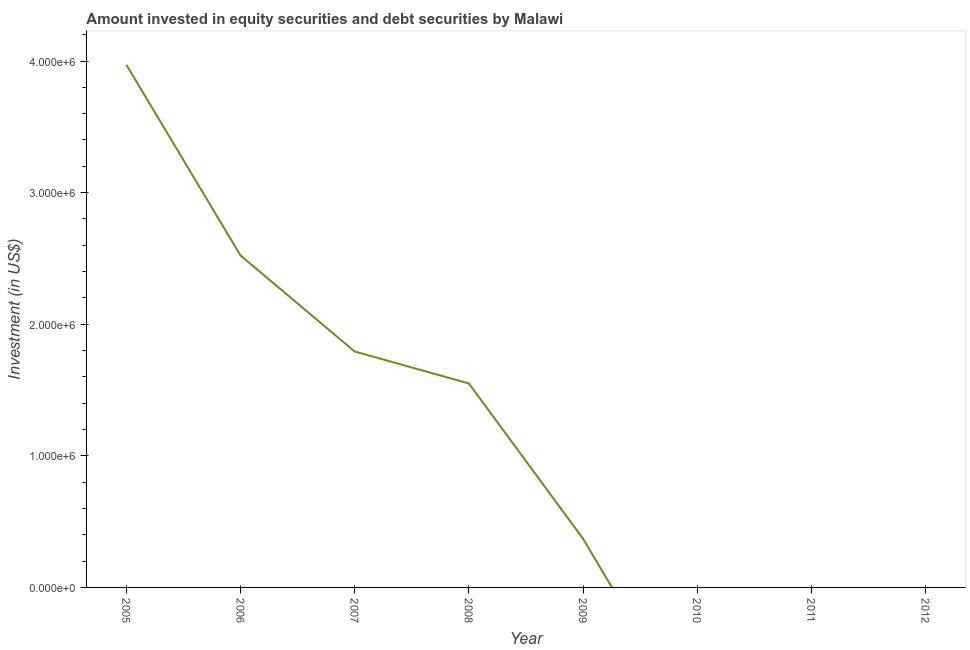What is the portfolio investment in 2007?
Keep it short and to the point. 1.79e+06. Across all years, what is the maximum portfolio investment?
Offer a terse response. 3.97e+06. In which year was the portfolio investment maximum?
Make the answer very short. 2005. What is the sum of the portfolio investment?
Provide a short and direct response. 1.02e+07. What is the difference between the portfolio investment in 2006 and 2009?
Provide a short and direct response. 2.15e+06. What is the average portfolio investment per year?
Give a very brief answer. 1.28e+06. What is the median portfolio investment?
Keep it short and to the point. 9.60e+05. In how many years, is the portfolio investment greater than 1400000 US$?
Provide a short and direct response. 4. What is the ratio of the portfolio investment in 2007 to that in 2008?
Offer a very short reply. 1.16. Is the portfolio investment in 2005 less than that in 2007?
Give a very brief answer. No. Is the difference between the portfolio investment in 2007 and 2009 greater than the difference between any two years?
Your answer should be very brief. No. What is the difference between the highest and the second highest portfolio investment?
Provide a short and direct response. 1.45e+06. What is the difference between the highest and the lowest portfolio investment?
Provide a succinct answer. 3.97e+06. In how many years, is the portfolio investment greater than the average portfolio investment taken over all years?
Provide a short and direct response. 4. Does the portfolio investment monotonically increase over the years?
Offer a terse response. No. How many years are there in the graph?
Provide a short and direct response. 8. Are the values on the major ticks of Y-axis written in scientific E-notation?
Your answer should be very brief. Yes. Does the graph contain grids?
Offer a terse response. No. What is the title of the graph?
Your answer should be very brief. Amount invested in equity securities and debt securities by Malawi. What is the label or title of the X-axis?
Make the answer very short. Year. What is the label or title of the Y-axis?
Offer a very short reply. Investment (in US$). What is the Investment (in US$) in 2005?
Offer a very short reply. 3.97e+06. What is the Investment (in US$) of 2006?
Your response must be concise. 2.52e+06. What is the Investment (in US$) of 2007?
Your answer should be compact. 1.79e+06. What is the Investment (in US$) in 2008?
Give a very brief answer. 1.55e+06. What is the Investment (in US$) of 2009?
Offer a very short reply. 3.70e+05. What is the Investment (in US$) in 2010?
Keep it short and to the point. 0. What is the Investment (in US$) of 2011?
Offer a very short reply. 0. What is the difference between the Investment (in US$) in 2005 and 2006?
Provide a short and direct response. 1.45e+06. What is the difference between the Investment (in US$) in 2005 and 2007?
Offer a terse response. 2.18e+06. What is the difference between the Investment (in US$) in 2005 and 2008?
Your answer should be compact. 2.42e+06. What is the difference between the Investment (in US$) in 2005 and 2009?
Provide a short and direct response. 3.60e+06. What is the difference between the Investment (in US$) in 2006 and 2007?
Make the answer very short. 7.30e+05. What is the difference between the Investment (in US$) in 2006 and 2008?
Provide a succinct answer. 9.72e+05. What is the difference between the Investment (in US$) in 2006 and 2009?
Keep it short and to the point. 2.15e+06. What is the difference between the Investment (in US$) in 2007 and 2008?
Offer a terse response. 2.43e+05. What is the difference between the Investment (in US$) in 2007 and 2009?
Ensure brevity in your answer.  1.42e+06. What is the difference between the Investment (in US$) in 2008 and 2009?
Keep it short and to the point. 1.18e+06. What is the ratio of the Investment (in US$) in 2005 to that in 2006?
Offer a terse response. 1.57. What is the ratio of the Investment (in US$) in 2005 to that in 2007?
Keep it short and to the point. 2.21. What is the ratio of the Investment (in US$) in 2005 to that in 2008?
Make the answer very short. 2.56. What is the ratio of the Investment (in US$) in 2005 to that in 2009?
Offer a very short reply. 10.73. What is the ratio of the Investment (in US$) in 2006 to that in 2007?
Ensure brevity in your answer.  1.41. What is the ratio of the Investment (in US$) in 2006 to that in 2008?
Make the answer very short. 1.63. What is the ratio of the Investment (in US$) in 2006 to that in 2009?
Your answer should be very brief. 6.82. What is the ratio of the Investment (in US$) in 2007 to that in 2008?
Keep it short and to the point. 1.16. What is the ratio of the Investment (in US$) in 2007 to that in 2009?
Provide a succinct answer. 4.84. What is the ratio of the Investment (in US$) in 2008 to that in 2009?
Provide a short and direct response. 4.19. 